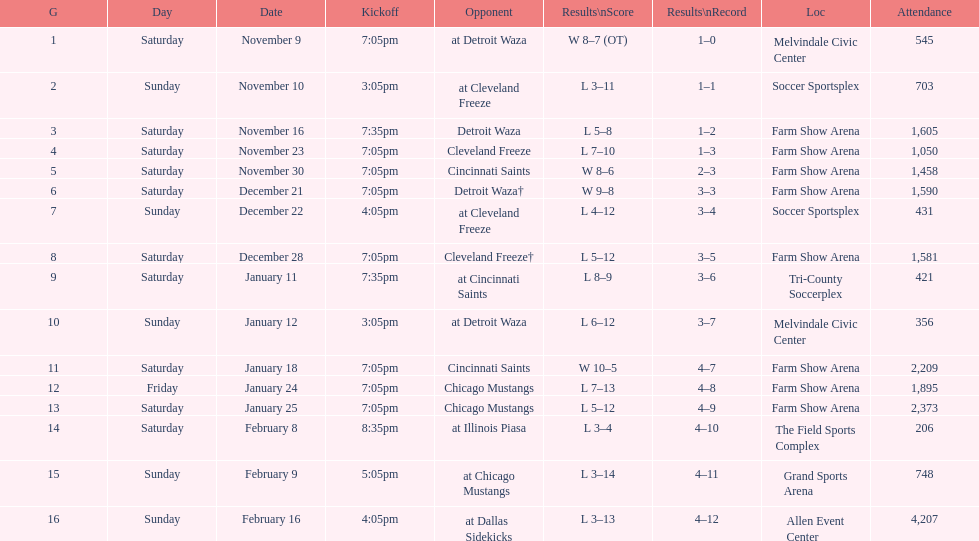How many games did the harrisburg heat win in which they scored eight or more goals? 4. 